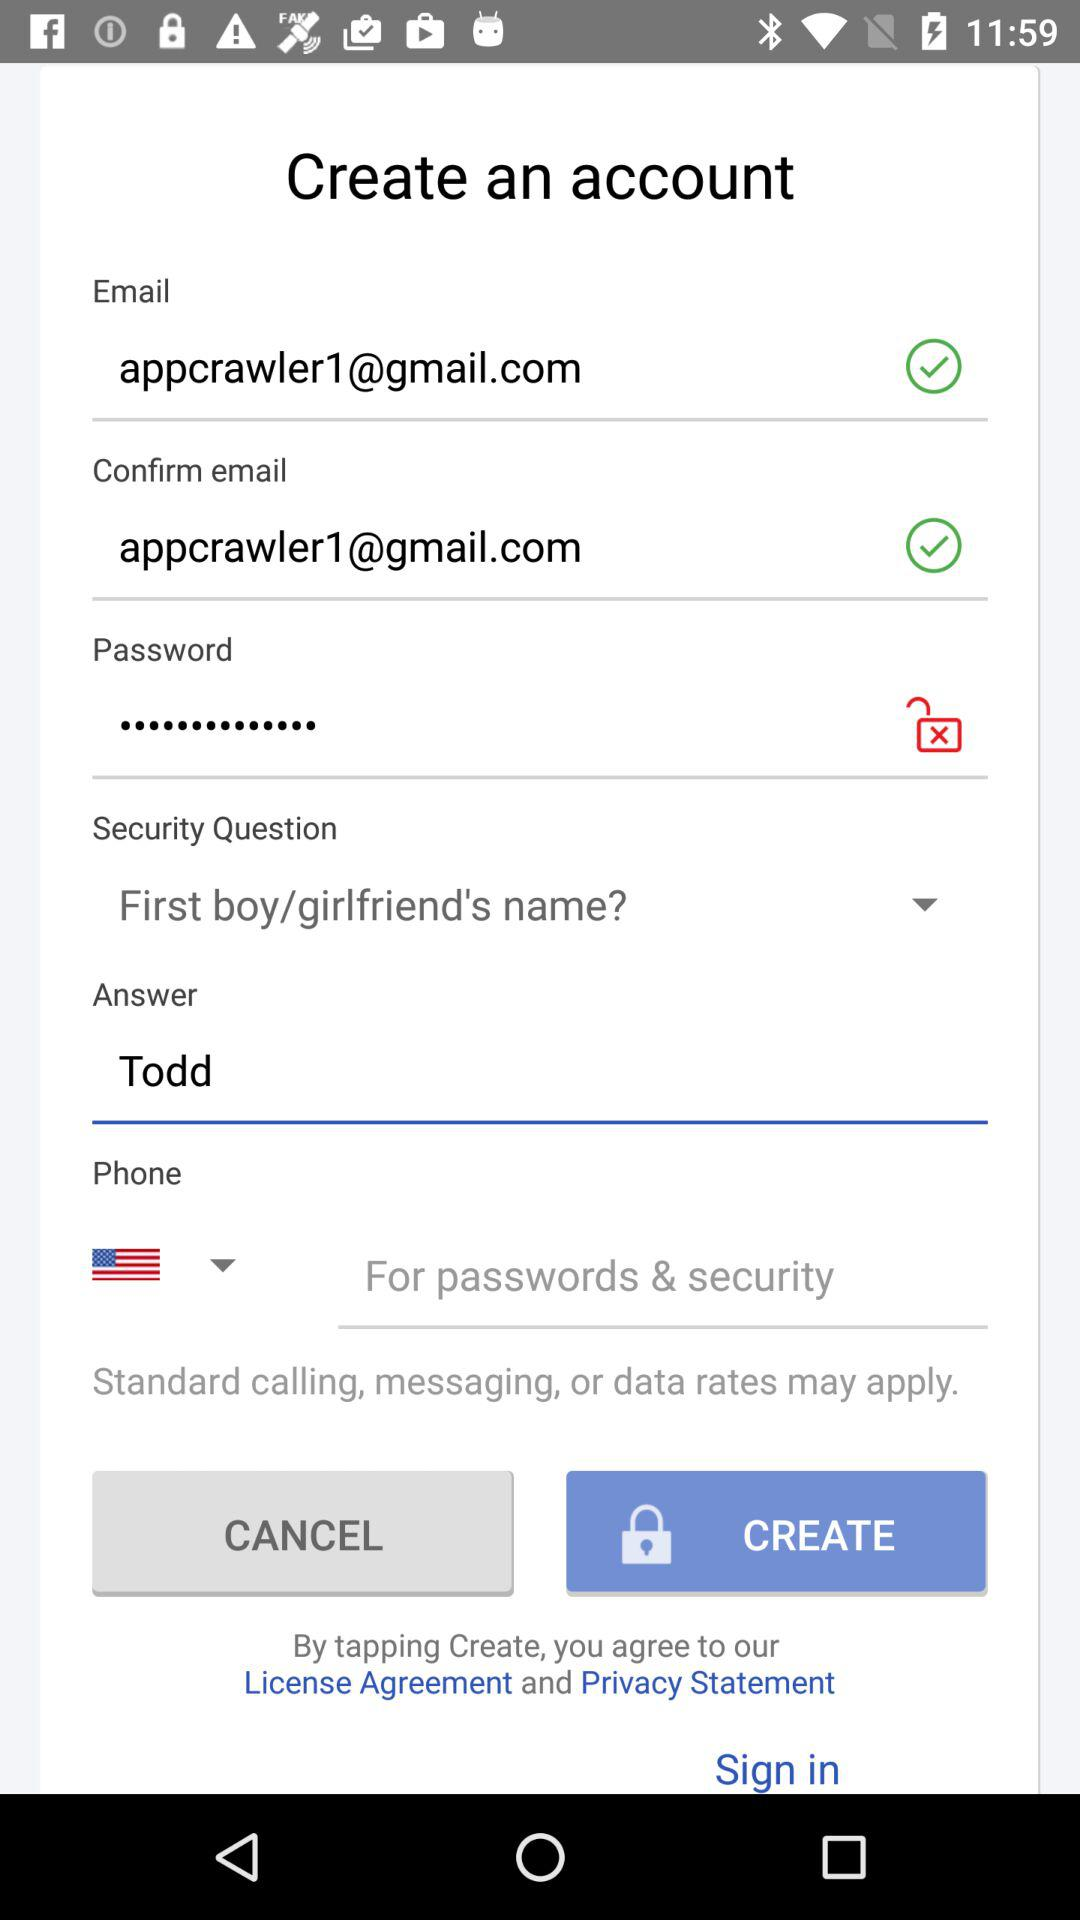What is the given Gmail address? The given Gmail address is appcrawler1@gmail.com. 